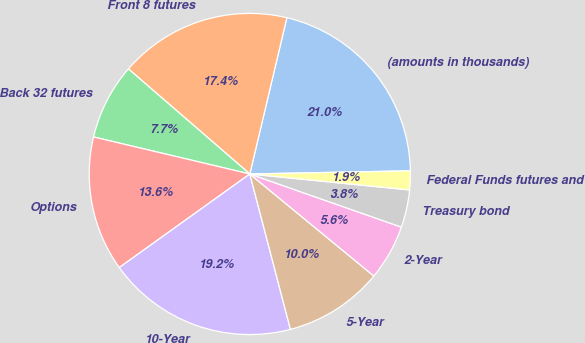Convert chart to OTSL. <chart><loc_0><loc_0><loc_500><loc_500><pie_chart><fcel>(amounts in thousands)<fcel>Front 8 futures<fcel>Back 32 futures<fcel>Options<fcel>10-Year<fcel>5-Year<fcel>2-Year<fcel>Treasury bond<fcel>Federal Funds futures and<nl><fcel>20.98%<fcel>17.35%<fcel>7.65%<fcel>13.6%<fcel>19.17%<fcel>9.97%<fcel>5.59%<fcel>3.78%<fcel>1.9%<nl></chart> 